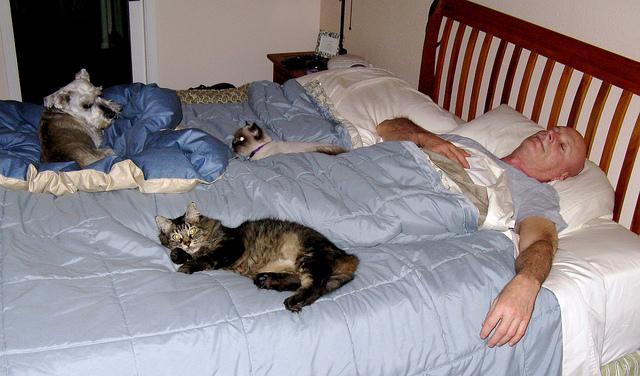How many species rest here? Please explain your reasoning. three. There are two different kinds of animals and a person here. 